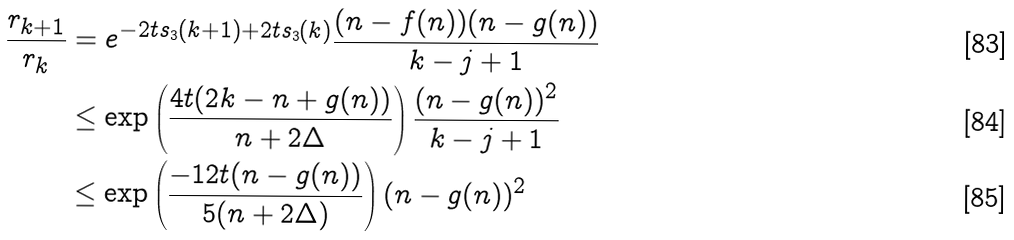Convert formula to latex. <formula><loc_0><loc_0><loc_500><loc_500>\frac { r _ { k + 1 } } { r _ { k } } & = e ^ { - 2 t s _ { 3 } ( k + 1 ) + 2 t s _ { 3 } ( k ) } \frac { ( n - f ( n ) ) ( n - g ( n ) ) } { k - j + 1 } \\ & \leq \exp \left ( \frac { 4 t ( 2 k - n + g ( n ) ) } { n + 2 \Delta } \right ) \frac { ( n - g ( n ) ) ^ { 2 } } { k - j + 1 } \\ & \leq \exp \left ( \frac { - 1 2 t ( n - g ( n ) ) } { 5 ( n + 2 \Delta ) } \right ) ( n - g ( n ) ) ^ { 2 }</formula> 